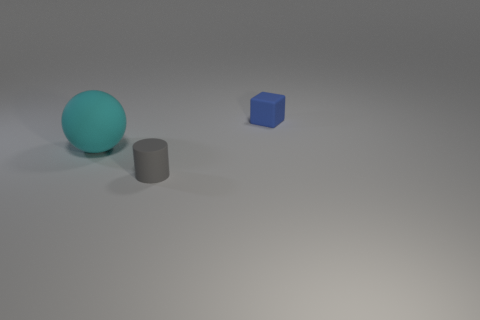Is there anything else that is the same shape as the tiny gray matte object?
Keep it short and to the point. No. Is there anything else that is the same size as the ball?
Ensure brevity in your answer.  No. There is a small thing behind the gray thing; is it the same shape as the gray object?
Your response must be concise. No. What color is the small object on the left side of the tiny object that is behind the big matte thing?
Provide a succinct answer. Gray. Are there fewer small blue rubber things than rubber objects?
Provide a short and direct response. Yes. Is there a cube that has the same material as the cylinder?
Your answer should be very brief. Yes. Is the shape of the large cyan matte thing the same as the thing that is to the right of the gray rubber cylinder?
Provide a short and direct response. No. There is a cylinder; are there any gray cylinders to the right of it?
Provide a short and direct response. No. What number of tiny gray things have the same shape as the large matte thing?
Your answer should be very brief. 0. Do the cylinder and the tiny thing on the right side of the small gray rubber object have the same material?
Provide a short and direct response. Yes. 